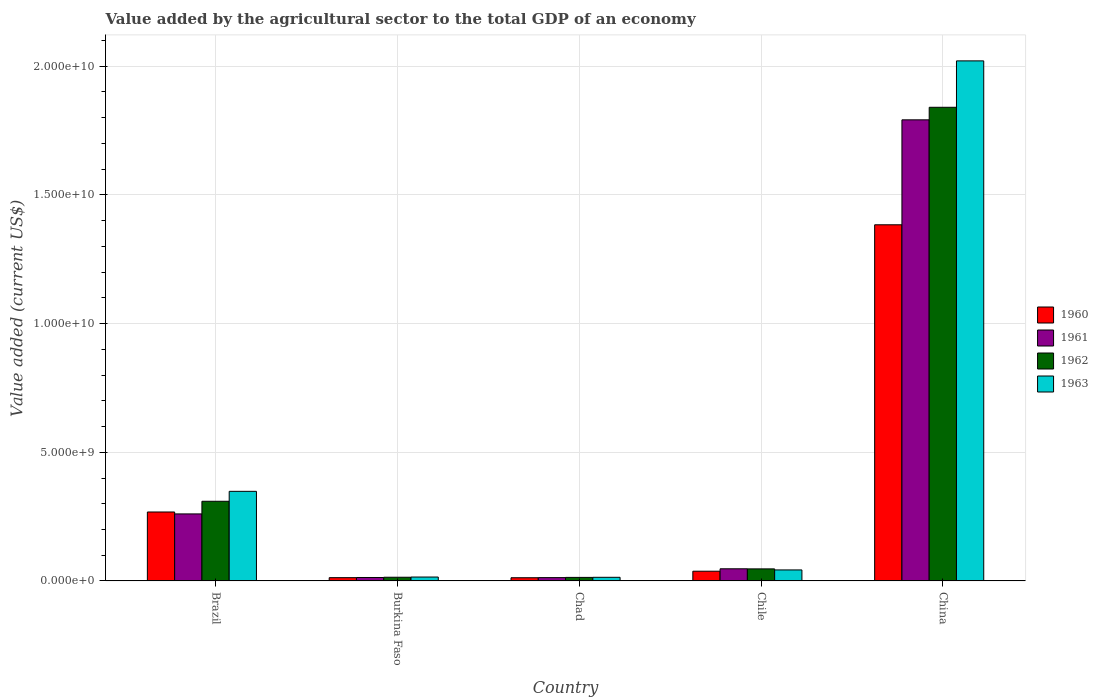How many different coloured bars are there?
Provide a short and direct response. 4. Are the number of bars per tick equal to the number of legend labels?
Your response must be concise. Yes. Are the number of bars on each tick of the X-axis equal?
Ensure brevity in your answer.  Yes. How many bars are there on the 2nd tick from the left?
Provide a short and direct response. 4. How many bars are there on the 1st tick from the right?
Give a very brief answer. 4. In how many cases, is the number of bars for a given country not equal to the number of legend labels?
Offer a very short reply. 0. What is the value added by the agricultural sector to the total GDP in 1962 in Burkina Faso?
Provide a succinct answer. 1.44e+08. Across all countries, what is the maximum value added by the agricultural sector to the total GDP in 1962?
Ensure brevity in your answer.  1.84e+1. Across all countries, what is the minimum value added by the agricultural sector to the total GDP in 1962?
Your response must be concise. 1.38e+08. In which country was the value added by the agricultural sector to the total GDP in 1962 maximum?
Your answer should be very brief. China. In which country was the value added by the agricultural sector to the total GDP in 1961 minimum?
Your response must be concise. Chad. What is the total value added by the agricultural sector to the total GDP in 1962 in the graph?
Your answer should be compact. 2.23e+1. What is the difference between the value added by the agricultural sector to the total GDP in 1963 in Brazil and that in Burkina Faso?
Your response must be concise. 3.33e+09. What is the difference between the value added by the agricultural sector to the total GDP in 1961 in Chile and the value added by the agricultural sector to the total GDP in 1962 in China?
Offer a very short reply. -1.79e+1. What is the average value added by the agricultural sector to the total GDP in 1963 per country?
Your response must be concise. 4.88e+09. What is the difference between the value added by the agricultural sector to the total GDP of/in 1963 and value added by the agricultural sector to the total GDP of/in 1961 in Chile?
Your answer should be very brief. -4.42e+07. In how many countries, is the value added by the agricultural sector to the total GDP in 1963 greater than 1000000000 US$?
Your response must be concise. 2. What is the ratio of the value added by the agricultural sector to the total GDP in 1962 in Burkina Faso to that in China?
Your answer should be very brief. 0.01. What is the difference between the highest and the second highest value added by the agricultural sector to the total GDP in 1961?
Give a very brief answer. 2.13e+09. What is the difference between the highest and the lowest value added by the agricultural sector to the total GDP in 1960?
Offer a terse response. 1.37e+1. Is it the case that in every country, the sum of the value added by the agricultural sector to the total GDP in 1961 and value added by the agricultural sector to the total GDP in 1963 is greater than the sum of value added by the agricultural sector to the total GDP in 1962 and value added by the agricultural sector to the total GDP in 1960?
Your answer should be compact. No. What does the 1st bar from the left in Burkina Faso represents?
Provide a short and direct response. 1960. Are all the bars in the graph horizontal?
Make the answer very short. No. How many legend labels are there?
Your response must be concise. 4. How are the legend labels stacked?
Offer a very short reply. Vertical. What is the title of the graph?
Your answer should be compact. Value added by the agricultural sector to the total GDP of an economy. What is the label or title of the Y-axis?
Give a very brief answer. Value added (current US$). What is the Value added (current US$) in 1960 in Brazil?
Offer a very short reply. 2.68e+09. What is the Value added (current US$) of 1961 in Brazil?
Your answer should be very brief. 2.60e+09. What is the Value added (current US$) of 1962 in Brazil?
Offer a terse response. 3.10e+09. What is the Value added (current US$) of 1963 in Brazil?
Give a very brief answer. 3.48e+09. What is the Value added (current US$) of 1960 in Burkina Faso?
Your answer should be very brief. 1.27e+08. What is the Value added (current US$) in 1961 in Burkina Faso?
Keep it short and to the point. 1.34e+08. What is the Value added (current US$) of 1962 in Burkina Faso?
Offer a terse response. 1.44e+08. What is the Value added (current US$) in 1963 in Burkina Faso?
Your response must be concise. 1.52e+08. What is the Value added (current US$) of 1960 in Chad?
Provide a short and direct response. 1.25e+08. What is the Value added (current US$) in 1961 in Chad?
Keep it short and to the point. 1.29e+08. What is the Value added (current US$) of 1962 in Chad?
Provide a succinct answer. 1.38e+08. What is the Value added (current US$) in 1963 in Chad?
Your answer should be very brief. 1.41e+08. What is the Value added (current US$) of 1960 in Chile?
Your response must be concise. 3.78e+08. What is the Value added (current US$) in 1961 in Chile?
Provide a succinct answer. 4.72e+08. What is the Value added (current US$) of 1962 in Chile?
Give a very brief answer. 4.69e+08. What is the Value added (current US$) of 1963 in Chile?
Give a very brief answer. 4.28e+08. What is the Value added (current US$) in 1960 in China?
Keep it short and to the point. 1.38e+1. What is the Value added (current US$) of 1961 in China?
Make the answer very short. 1.79e+1. What is the Value added (current US$) in 1962 in China?
Make the answer very short. 1.84e+1. What is the Value added (current US$) of 1963 in China?
Make the answer very short. 2.02e+1. Across all countries, what is the maximum Value added (current US$) in 1960?
Make the answer very short. 1.38e+1. Across all countries, what is the maximum Value added (current US$) in 1961?
Your answer should be compact. 1.79e+1. Across all countries, what is the maximum Value added (current US$) in 1962?
Provide a short and direct response. 1.84e+1. Across all countries, what is the maximum Value added (current US$) in 1963?
Your answer should be compact. 2.02e+1. Across all countries, what is the minimum Value added (current US$) in 1960?
Offer a terse response. 1.25e+08. Across all countries, what is the minimum Value added (current US$) of 1961?
Keep it short and to the point. 1.29e+08. Across all countries, what is the minimum Value added (current US$) of 1962?
Your answer should be very brief. 1.38e+08. Across all countries, what is the minimum Value added (current US$) of 1963?
Give a very brief answer. 1.41e+08. What is the total Value added (current US$) of 1960 in the graph?
Ensure brevity in your answer.  1.71e+1. What is the total Value added (current US$) of 1961 in the graph?
Offer a very short reply. 2.13e+1. What is the total Value added (current US$) of 1962 in the graph?
Provide a succinct answer. 2.23e+1. What is the total Value added (current US$) in 1963 in the graph?
Your answer should be very brief. 2.44e+1. What is the difference between the Value added (current US$) of 1960 in Brazil and that in Burkina Faso?
Keep it short and to the point. 2.55e+09. What is the difference between the Value added (current US$) of 1961 in Brazil and that in Burkina Faso?
Your response must be concise. 2.47e+09. What is the difference between the Value added (current US$) in 1962 in Brazil and that in Burkina Faso?
Keep it short and to the point. 2.95e+09. What is the difference between the Value added (current US$) in 1963 in Brazil and that in Burkina Faso?
Offer a very short reply. 3.33e+09. What is the difference between the Value added (current US$) in 1960 in Brazil and that in Chad?
Give a very brief answer. 2.55e+09. What is the difference between the Value added (current US$) in 1961 in Brazil and that in Chad?
Keep it short and to the point. 2.48e+09. What is the difference between the Value added (current US$) of 1962 in Brazil and that in Chad?
Provide a short and direct response. 2.96e+09. What is the difference between the Value added (current US$) of 1963 in Brazil and that in Chad?
Provide a short and direct response. 3.34e+09. What is the difference between the Value added (current US$) of 1960 in Brazil and that in Chile?
Offer a terse response. 2.30e+09. What is the difference between the Value added (current US$) in 1961 in Brazil and that in Chile?
Keep it short and to the point. 2.13e+09. What is the difference between the Value added (current US$) in 1962 in Brazil and that in Chile?
Provide a succinct answer. 2.63e+09. What is the difference between the Value added (current US$) in 1963 in Brazil and that in Chile?
Offer a terse response. 3.05e+09. What is the difference between the Value added (current US$) of 1960 in Brazil and that in China?
Ensure brevity in your answer.  -1.12e+1. What is the difference between the Value added (current US$) of 1961 in Brazil and that in China?
Provide a succinct answer. -1.53e+1. What is the difference between the Value added (current US$) of 1962 in Brazil and that in China?
Offer a very short reply. -1.53e+1. What is the difference between the Value added (current US$) in 1963 in Brazil and that in China?
Give a very brief answer. -1.67e+1. What is the difference between the Value added (current US$) in 1960 in Burkina Faso and that in Chad?
Give a very brief answer. 2.61e+06. What is the difference between the Value added (current US$) in 1961 in Burkina Faso and that in Chad?
Offer a terse response. 4.79e+06. What is the difference between the Value added (current US$) of 1962 in Burkina Faso and that in Chad?
Offer a very short reply. 6.10e+06. What is the difference between the Value added (current US$) in 1963 in Burkina Faso and that in Chad?
Your response must be concise. 1.03e+07. What is the difference between the Value added (current US$) of 1960 in Burkina Faso and that in Chile?
Provide a succinct answer. -2.51e+08. What is the difference between the Value added (current US$) of 1961 in Burkina Faso and that in Chile?
Your response must be concise. -3.38e+08. What is the difference between the Value added (current US$) of 1962 in Burkina Faso and that in Chile?
Provide a short and direct response. -3.25e+08. What is the difference between the Value added (current US$) of 1963 in Burkina Faso and that in Chile?
Your answer should be very brief. -2.76e+08. What is the difference between the Value added (current US$) of 1960 in Burkina Faso and that in China?
Ensure brevity in your answer.  -1.37e+1. What is the difference between the Value added (current US$) in 1961 in Burkina Faso and that in China?
Your response must be concise. -1.78e+1. What is the difference between the Value added (current US$) of 1962 in Burkina Faso and that in China?
Provide a short and direct response. -1.83e+1. What is the difference between the Value added (current US$) in 1963 in Burkina Faso and that in China?
Give a very brief answer. -2.01e+1. What is the difference between the Value added (current US$) in 1960 in Chad and that in Chile?
Provide a succinct answer. -2.54e+08. What is the difference between the Value added (current US$) in 1961 in Chad and that in Chile?
Give a very brief answer. -3.43e+08. What is the difference between the Value added (current US$) in 1962 in Chad and that in Chile?
Offer a very short reply. -3.31e+08. What is the difference between the Value added (current US$) of 1963 in Chad and that in Chile?
Make the answer very short. -2.87e+08. What is the difference between the Value added (current US$) of 1960 in Chad and that in China?
Make the answer very short. -1.37e+1. What is the difference between the Value added (current US$) of 1961 in Chad and that in China?
Keep it short and to the point. -1.78e+1. What is the difference between the Value added (current US$) in 1962 in Chad and that in China?
Ensure brevity in your answer.  -1.83e+1. What is the difference between the Value added (current US$) of 1963 in Chad and that in China?
Provide a succinct answer. -2.01e+1. What is the difference between the Value added (current US$) in 1960 in Chile and that in China?
Give a very brief answer. -1.35e+1. What is the difference between the Value added (current US$) in 1961 in Chile and that in China?
Your answer should be compact. -1.74e+1. What is the difference between the Value added (current US$) in 1962 in Chile and that in China?
Provide a succinct answer. -1.79e+1. What is the difference between the Value added (current US$) in 1963 in Chile and that in China?
Provide a succinct answer. -1.98e+1. What is the difference between the Value added (current US$) in 1960 in Brazil and the Value added (current US$) in 1961 in Burkina Faso?
Offer a terse response. 2.55e+09. What is the difference between the Value added (current US$) in 1960 in Brazil and the Value added (current US$) in 1962 in Burkina Faso?
Provide a short and direct response. 2.54e+09. What is the difference between the Value added (current US$) in 1960 in Brazil and the Value added (current US$) in 1963 in Burkina Faso?
Ensure brevity in your answer.  2.53e+09. What is the difference between the Value added (current US$) in 1961 in Brazil and the Value added (current US$) in 1962 in Burkina Faso?
Make the answer very short. 2.46e+09. What is the difference between the Value added (current US$) of 1961 in Brazil and the Value added (current US$) of 1963 in Burkina Faso?
Your answer should be compact. 2.45e+09. What is the difference between the Value added (current US$) in 1962 in Brazil and the Value added (current US$) in 1963 in Burkina Faso?
Give a very brief answer. 2.94e+09. What is the difference between the Value added (current US$) in 1960 in Brazil and the Value added (current US$) in 1961 in Chad?
Provide a succinct answer. 2.55e+09. What is the difference between the Value added (current US$) of 1960 in Brazil and the Value added (current US$) of 1962 in Chad?
Your response must be concise. 2.54e+09. What is the difference between the Value added (current US$) in 1960 in Brazil and the Value added (current US$) in 1963 in Chad?
Provide a short and direct response. 2.54e+09. What is the difference between the Value added (current US$) in 1961 in Brazil and the Value added (current US$) in 1962 in Chad?
Give a very brief answer. 2.47e+09. What is the difference between the Value added (current US$) of 1961 in Brazil and the Value added (current US$) of 1963 in Chad?
Your answer should be very brief. 2.46e+09. What is the difference between the Value added (current US$) in 1962 in Brazil and the Value added (current US$) in 1963 in Chad?
Offer a terse response. 2.95e+09. What is the difference between the Value added (current US$) of 1960 in Brazil and the Value added (current US$) of 1961 in Chile?
Your answer should be very brief. 2.21e+09. What is the difference between the Value added (current US$) in 1960 in Brazil and the Value added (current US$) in 1962 in Chile?
Make the answer very short. 2.21e+09. What is the difference between the Value added (current US$) in 1960 in Brazil and the Value added (current US$) in 1963 in Chile?
Offer a very short reply. 2.25e+09. What is the difference between the Value added (current US$) of 1961 in Brazil and the Value added (current US$) of 1962 in Chile?
Your answer should be very brief. 2.14e+09. What is the difference between the Value added (current US$) of 1961 in Brazil and the Value added (current US$) of 1963 in Chile?
Your response must be concise. 2.18e+09. What is the difference between the Value added (current US$) of 1962 in Brazil and the Value added (current US$) of 1963 in Chile?
Provide a succinct answer. 2.67e+09. What is the difference between the Value added (current US$) in 1960 in Brazil and the Value added (current US$) in 1961 in China?
Ensure brevity in your answer.  -1.52e+1. What is the difference between the Value added (current US$) in 1960 in Brazil and the Value added (current US$) in 1962 in China?
Provide a succinct answer. -1.57e+1. What is the difference between the Value added (current US$) of 1960 in Brazil and the Value added (current US$) of 1963 in China?
Keep it short and to the point. -1.75e+1. What is the difference between the Value added (current US$) in 1961 in Brazil and the Value added (current US$) in 1962 in China?
Provide a succinct answer. -1.58e+1. What is the difference between the Value added (current US$) in 1961 in Brazil and the Value added (current US$) in 1963 in China?
Ensure brevity in your answer.  -1.76e+1. What is the difference between the Value added (current US$) of 1962 in Brazil and the Value added (current US$) of 1963 in China?
Offer a very short reply. -1.71e+1. What is the difference between the Value added (current US$) of 1960 in Burkina Faso and the Value added (current US$) of 1961 in Chad?
Offer a very short reply. -2.21e+06. What is the difference between the Value added (current US$) of 1960 in Burkina Faso and the Value added (current US$) of 1962 in Chad?
Offer a very short reply. -1.04e+07. What is the difference between the Value added (current US$) of 1960 in Burkina Faso and the Value added (current US$) of 1963 in Chad?
Offer a very short reply. -1.42e+07. What is the difference between the Value added (current US$) of 1961 in Burkina Faso and the Value added (current US$) of 1962 in Chad?
Your answer should be very brief. -3.43e+06. What is the difference between the Value added (current US$) of 1961 in Burkina Faso and the Value added (current US$) of 1963 in Chad?
Give a very brief answer. -7.20e+06. What is the difference between the Value added (current US$) of 1962 in Burkina Faso and the Value added (current US$) of 1963 in Chad?
Ensure brevity in your answer.  2.33e+06. What is the difference between the Value added (current US$) in 1960 in Burkina Faso and the Value added (current US$) in 1961 in Chile?
Your answer should be very brief. -3.45e+08. What is the difference between the Value added (current US$) in 1960 in Burkina Faso and the Value added (current US$) in 1962 in Chile?
Ensure brevity in your answer.  -3.41e+08. What is the difference between the Value added (current US$) in 1960 in Burkina Faso and the Value added (current US$) in 1963 in Chile?
Give a very brief answer. -3.01e+08. What is the difference between the Value added (current US$) in 1961 in Burkina Faso and the Value added (current US$) in 1962 in Chile?
Provide a succinct answer. -3.34e+08. What is the difference between the Value added (current US$) in 1961 in Burkina Faso and the Value added (current US$) in 1963 in Chile?
Make the answer very short. -2.94e+08. What is the difference between the Value added (current US$) of 1962 in Burkina Faso and the Value added (current US$) of 1963 in Chile?
Provide a succinct answer. -2.84e+08. What is the difference between the Value added (current US$) in 1960 in Burkina Faso and the Value added (current US$) in 1961 in China?
Provide a succinct answer. -1.78e+1. What is the difference between the Value added (current US$) in 1960 in Burkina Faso and the Value added (current US$) in 1962 in China?
Your answer should be very brief. -1.83e+1. What is the difference between the Value added (current US$) in 1960 in Burkina Faso and the Value added (current US$) in 1963 in China?
Keep it short and to the point. -2.01e+1. What is the difference between the Value added (current US$) in 1961 in Burkina Faso and the Value added (current US$) in 1962 in China?
Your response must be concise. -1.83e+1. What is the difference between the Value added (current US$) in 1961 in Burkina Faso and the Value added (current US$) in 1963 in China?
Your answer should be very brief. -2.01e+1. What is the difference between the Value added (current US$) in 1962 in Burkina Faso and the Value added (current US$) in 1963 in China?
Offer a terse response. -2.01e+1. What is the difference between the Value added (current US$) in 1960 in Chad and the Value added (current US$) in 1961 in Chile?
Give a very brief answer. -3.48e+08. What is the difference between the Value added (current US$) in 1960 in Chad and the Value added (current US$) in 1962 in Chile?
Provide a short and direct response. -3.44e+08. What is the difference between the Value added (current US$) of 1960 in Chad and the Value added (current US$) of 1963 in Chile?
Your answer should be very brief. -3.03e+08. What is the difference between the Value added (current US$) of 1961 in Chad and the Value added (current US$) of 1962 in Chile?
Your response must be concise. -3.39e+08. What is the difference between the Value added (current US$) of 1961 in Chad and the Value added (current US$) of 1963 in Chile?
Your answer should be very brief. -2.99e+08. What is the difference between the Value added (current US$) of 1962 in Chad and the Value added (current US$) of 1963 in Chile?
Your answer should be compact. -2.90e+08. What is the difference between the Value added (current US$) of 1960 in Chad and the Value added (current US$) of 1961 in China?
Give a very brief answer. -1.78e+1. What is the difference between the Value added (current US$) in 1960 in Chad and the Value added (current US$) in 1962 in China?
Your answer should be compact. -1.83e+1. What is the difference between the Value added (current US$) of 1960 in Chad and the Value added (current US$) of 1963 in China?
Provide a short and direct response. -2.01e+1. What is the difference between the Value added (current US$) in 1961 in Chad and the Value added (current US$) in 1962 in China?
Ensure brevity in your answer.  -1.83e+1. What is the difference between the Value added (current US$) in 1961 in Chad and the Value added (current US$) in 1963 in China?
Your answer should be compact. -2.01e+1. What is the difference between the Value added (current US$) of 1962 in Chad and the Value added (current US$) of 1963 in China?
Your answer should be very brief. -2.01e+1. What is the difference between the Value added (current US$) of 1960 in Chile and the Value added (current US$) of 1961 in China?
Make the answer very short. -1.75e+1. What is the difference between the Value added (current US$) in 1960 in Chile and the Value added (current US$) in 1962 in China?
Provide a succinct answer. -1.80e+1. What is the difference between the Value added (current US$) of 1960 in Chile and the Value added (current US$) of 1963 in China?
Your response must be concise. -1.98e+1. What is the difference between the Value added (current US$) of 1961 in Chile and the Value added (current US$) of 1962 in China?
Ensure brevity in your answer.  -1.79e+1. What is the difference between the Value added (current US$) in 1961 in Chile and the Value added (current US$) in 1963 in China?
Offer a very short reply. -1.97e+1. What is the difference between the Value added (current US$) in 1962 in Chile and the Value added (current US$) in 1963 in China?
Make the answer very short. -1.97e+1. What is the average Value added (current US$) in 1960 per country?
Provide a succinct answer. 3.43e+09. What is the average Value added (current US$) in 1961 per country?
Keep it short and to the point. 4.25e+09. What is the average Value added (current US$) of 1962 per country?
Provide a short and direct response. 4.45e+09. What is the average Value added (current US$) in 1963 per country?
Keep it short and to the point. 4.88e+09. What is the difference between the Value added (current US$) of 1960 and Value added (current US$) of 1961 in Brazil?
Make the answer very short. 7.45e+07. What is the difference between the Value added (current US$) of 1960 and Value added (current US$) of 1962 in Brazil?
Provide a short and direct response. -4.16e+08. What is the difference between the Value added (current US$) of 1960 and Value added (current US$) of 1963 in Brazil?
Your response must be concise. -8.03e+08. What is the difference between the Value added (current US$) in 1961 and Value added (current US$) in 1962 in Brazil?
Offer a terse response. -4.91e+08. What is the difference between the Value added (current US$) in 1961 and Value added (current US$) in 1963 in Brazil?
Provide a succinct answer. -8.77e+08. What is the difference between the Value added (current US$) in 1962 and Value added (current US$) in 1963 in Brazil?
Offer a terse response. -3.87e+08. What is the difference between the Value added (current US$) in 1960 and Value added (current US$) in 1961 in Burkina Faso?
Keep it short and to the point. -7.00e+06. What is the difference between the Value added (current US$) in 1960 and Value added (current US$) in 1962 in Burkina Faso?
Provide a succinct answer. -1.65e+07. What is the difference between the Value added (current US$) of 1960 and Value added (current US$) of 1963 in Burkina Faso?
Offer a very short reply. -2.45e+07. What is the difference between the Value added (current US$) of 1961 and Value added (current US$) of 1962 in Burkina Faso?
Your answer should be compact. -9.53e+06. What is the difference between the Value added (current US$) in 1961 and Value added (current US$) in 1963 in Burkina Faso?
Provide a short and direct response. -1.75e+07. What is the difference between the Value added (current US$) in 1962 and Value added (current US$) in 1963 in Burkina Faso?
Offer a terse response. -7.98e+06. What is the difference between the Value added (current US$) in 1960 and Value added (current US$) in 1961 in Chad?
Your response must be concise. -4.82e+06. What is the difference between the Value added (current US$) in 1960 and Value added (current US$) in 1962 in Chad?
Make the answer very short. -1.30e+07. What is the difference between the Value added (current US$) in 1960 and Value added (current US$) in 1963 in Chad?
Provide a short and direct response. -1.68e+07. What is the difference between the Value added (current US$) in 1961 and Value added (current US$) in 1962 in Chad?
Provide a succinct answer. -8.22e+06. What is the difference between the Value added (current US$) of 1961 and Value added (current US$) of 1963 in Chad?
Provide a succinct answer. -1.20e+07. What is the difference between the Value added (current US$) in 1962 and Value added (current US$) in 1963 in Chad?
Give a very brief answer. -3.78e+06. What is the difference between the Value added (current US$) of 1960 and Value added (current US$) of 1961 in Chile?
Ensure brevity in your answer.  -9.41e+07. What is the difference between the Value added (current US$) of 1960 and Value added (current US$) of 1962 in Chile?
Ensure brevity in your answer.  -9.05e+07. What is the difference between the Value added (current US$) of 1960 and Value added (current US$) of 1963 in Chile?
Provide a succinct answer. -4.98e+07. What is the difference between the Value added (current US$) in 1961 and Value added (current US$) in 1962 in Chile?
Offer a very short reply. 3.57e+06. What is the difference between the Value added (current US$) in 1961 and Value added (current US$) in 1963 in Chile?
Keep it short and to the point. 4.42e+07. What is the difference between the Value added (current US$) in 1962 and Value added (current US$) in 1963 in Chile?
Provide a short and direct response. 4.07e+07. What is the difference between the Value added (current US$) of 1960 and Value added (current US$) of 1961 in China?
Make the answer very short. -4.08e+09. What is the difference between the Value added (current US$) of 1960 and Value added (current US$) of 1962 in China?
Your answer should be very brief. -4.57e+09. What is the difference between the Value added (current US$) of 1960 and Value added (current US$) of 1963 in China?
Offer a terse response. -6.37e+09. What is the difference between the Value added (current US$) in 1961 and Value added (current US$) in 1962 in China?
Keep it short and to the point. -4.87e+08. What is the difference between the Value added (current US$) in 1961 and Value added (current US$) in 1963 in China?
Offer a terse response. -2.29e+09. What is the difference between the Value added (current US$) of 1962 and Value added (current US$) of 1963 in China?
Make the answer very short. -1.80e+09. What is the ratio of the Value added (current US$) of 1960 in Brazil to that in Burkina Faso?
Your answer should be very brief. 21.07. What is the ratio of the Value added (current US$) in 1961 in Brazil to that in Burkina Faso?
Keep it short and to the point. 19.41. What is the ratio of the Value added (current US$) in 1962 in Brazil to that in Burkina Faso?
Your response must be concise. 21.54. What is the ratio of the Value added (current US$) in 1963 in Brazil to that in Burkina Faso?
Provide a succinct answer. 22.96. What is the ratio of the Value added (current US$) of 1960 in Brazil to that in Chad?
Offer a terse response. 21.51. What is the ratio of the Value added (current US$) of 1961 in Brazil to that in Chad?
Provide a short and direct response. 20.13. What is the ratio of the Value added (current US$) in 1962 in Brazil to that in Chad?
Make the answer very short. 22.5. What is the ratio of the Value added (current US$) of 1963 in Brazil to that in Chad?
Your response must be concise. 24.63. What is the ratio of the Value added (current US$) in 1960 in Brazil to that in Chile?
Your response must be concise. 7.09. What is the ratio of the Value added (current US$) of 1961 in Brazil to that in Chile?
Your response must be concise. 5.52. What is the ratio of the Value added (current US$) in 1962 in Brazil to that in Chile?
Provide a succinct answer. 6.61. What is the ratio of the Value added (current US$) in 1963 in Brazil to that in Chile?
Provide a short and direct response. 8.14. What is the ratio of the Value added (current US$) in 1960 in Brazil to that in China?
Provide a short and direct response. 0.19. What is the ratio of the Value added (current US$) in 1961 in Brazil to that in China?
Your response must be concise. 0.15. What is the ratio of the Value added (current US$) of 1962 in Brazil to that in China?
Make the answer very short. 0.17. What is the ratio of the Value added (current US$) of 1963 in Brazil to that in China?
Offer a terse response. 0.17. What is the ratio of the Value added (current US$) in 1960 in Burkina Faso to that in Chad?
Provide a short and direct response. 1.02. What is the ratio of the Value added (current US$) of 1961 in Burkina Faso to that in Chad?
Your answer should be very brief. 1.04. What is the ratio of the Value added (current US$) of 1962 in Burkina Faso to that in Chad?
Keep it short and to the point. 1.04. What is the ratio of the Value added (current US$) in 1963 in Burkina Faso to that in Chad?
Keep it short and to the point. 1.07. What is the ratio of the Value added (current US$) in 1960 in Burkina Faso to that in Chile?
Provide a succinct answer. 0.34. What is the ratio of the Value added (current US$) in 1961 in Burkina Faso to that in Chile?
Give a very brief answer. 0.28. What is the ratio of the Value added (current US$) in 1962 in Burkina Faso to that in Chile?
Offer a terse response. 0.31. What is the ratio of the Value added (current US$) of 1963 in Burkina Faso to that in Chile?
Provide a short and direct response. 0.35. What is the ratio of the Value added (current US$) of 1960 in Burkina Faso to that in China?
Make the answer very short. 0.01. What is the ratio of the Value added (current US$) of 1961 in Burkina Faso to that in China?
Make the answer very short. 0.01. What is the ratio of the Value added (current US$) of 1962 in Burkina Faso to that in China?
Keep it short and to the point. 0.01. What is the ratio of the Value added (current US$) of 1963 in Burkina Faso to that in China?
Make the answer very short. 0.01. What is the ratio of the Value added (current US$) of 1960 in Chad to that in Chile?
Keep it short and to the point. 0.33. What is the ratio of the Value added (current US$) in 1961 in Chad to that in Chile?
Provide a short and direct response. 0.27. What is the ratio of the Value added (current US$) in 1962 in Chad to that in Chile?
Your response must be concise. 0.29. What is the ratio of the Value added (current US$) of 1963 in Chad to that in Chile?
Your response must be concise. 0.33. What is the ratio of the Value added (current US$) of 1960 in Chad to that in China?
Make the answer very short. 0.01. What is the ratio of the Value added (current US$) of 1961 in Chad to that in China?
Ensure brevity in your answer.  0.01. What is the ratio of the Value added (current US$) of 1962 in Chad to that in China?
Provide a succinct answer. 0.01. What is the ratio of the Value added (current US$) in 1963 in Chad to that in China?
Offer a terse response. 0.01. What is the ratio of the Value added (current US$) of 1960 in Chile to that in China?
Ensure brevity in your answer.  0.03. What is the ratio of the Value added (current US$) of 1961 in Chile to that in China?
Ensure brevity in your answer.  0.03. What is the ratio of the Value added (current US$) in 1962 in Chile to that in China?
Offer a very short reply. 0.03. What is the ratio of the Value added (current US$) in 1963 in Chile to that in China?
Your answer should be very brief. 0.02. What is the difference between the highest and the second highest Value added (current US$) in 1960?
Your response must be concise. 1.12e+1. What is the difference between the highest and the second highest Value added (current US$) of 1961?
Offer a very short reply. 1.53e+1. What is the difference between the highest and the second highest Value added (current US$) of 1962?
Your answer should be very brief. 1.53e+1. What is the difference between the highest and the second highest Value added (current US$) in 1963?
Provide a short and direct response. 1.67e+1. What is the difference between the highest and the lowest Value added (current US$) of 1960?
Provide a short and direct response. 1.37e+1. What is the difference between the highest and the lowest Value added (current US$) of 1961?
Provide a succinct answer. 1.78e+1. What is the difference between the highest and the lowest Value added (current US$) of 1962?
Provide a short and direct response. 1.83e+1. What is the difference between the highest and the lowest Value added (current US$) in 1963?
Provide a short and direct response. 2.01e+1. 